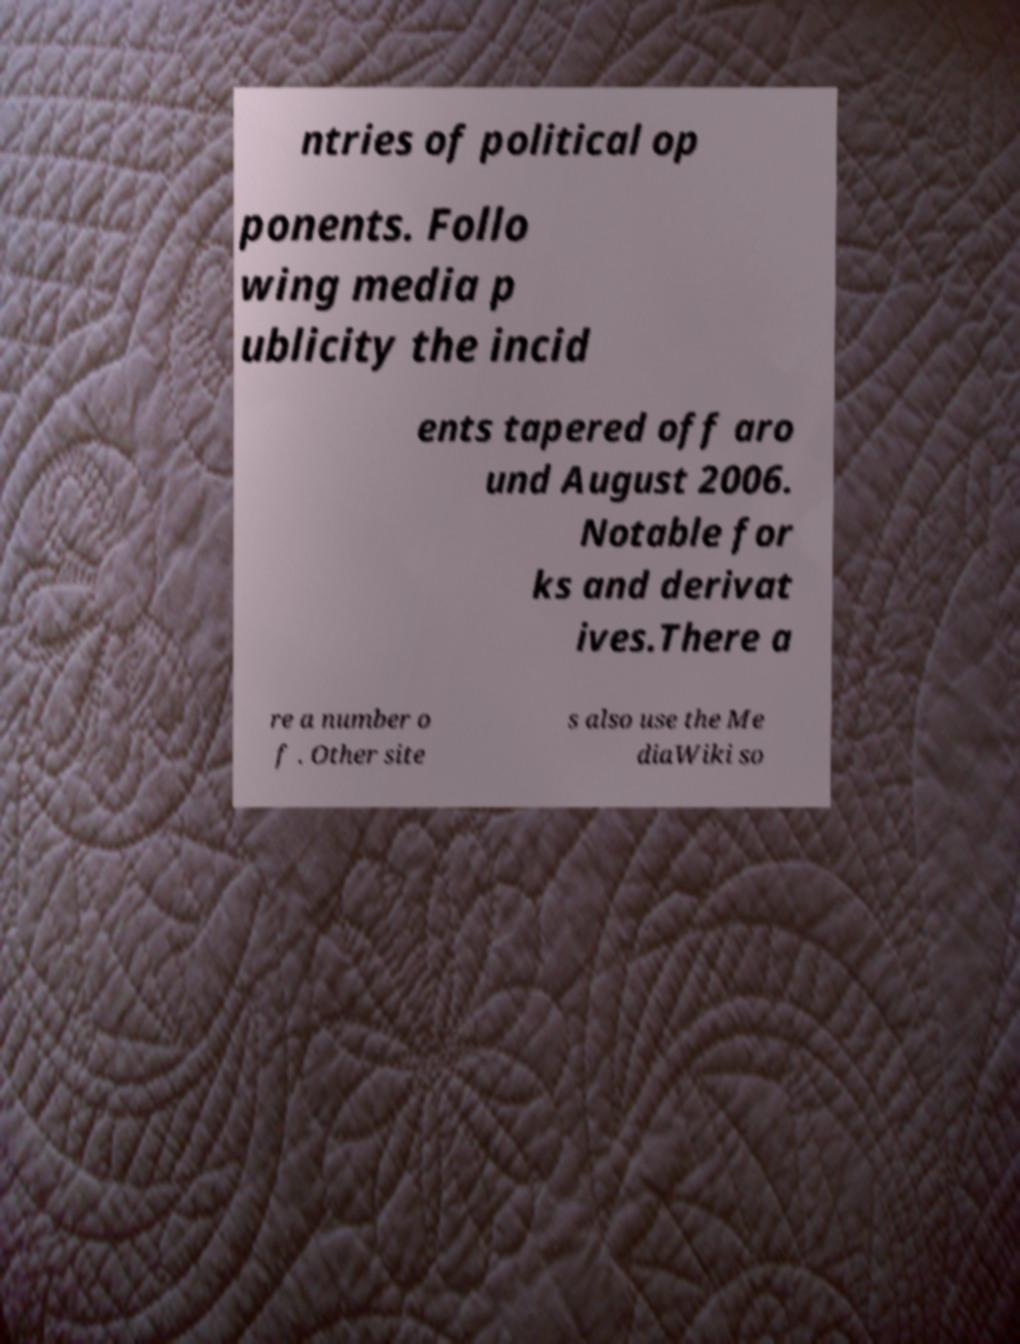Can you read and provide the text displayed in the image?This photo seems to have some interesting text. Can you extract and type it out for me? ntries of political op ponents. Follo wing media p ublicity the incid ents tapered off aro und August 2006. Notable for ks and derivat ives.There a re a number o f . Other site s also use the Me diaWiki so 